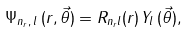<formula> <loc_0><loc_0><loc_500><loc_500>\Psi _ { n _ { r } , \, { l } } \, ( r , { \vec { \theta } } ) = R _ { n _ { r } l } ( r ) \, Y _ { l } \, ( { \vec { \theta } } ) ,</formula> 